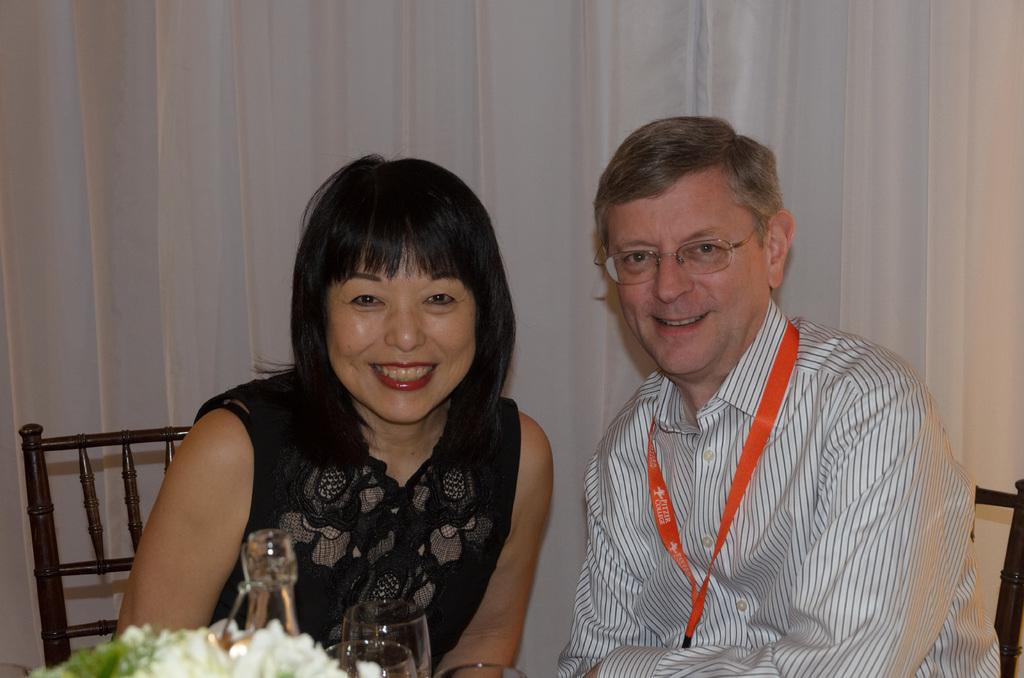Who is present in the image? There is a man and a woman in the image. What are the expressions on their faces? Both the man and the woman are smiling in the image. What objects can be seen in the image? There are glasses and flowers visible in the image. What is in the background of the image? There is a curtain in the background of the image. Can you tell me how many aunts are present in the image? There are no aunts mentioned or visible in the image; it features a man and a woman. What type of structure is depicted in the image? There is no specific structure depicted in the image; it shows a man, a woman, and various objects. 